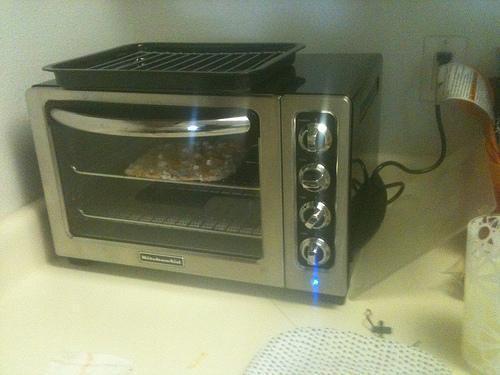How many people are visible?
Give a very brief answer. 0. 